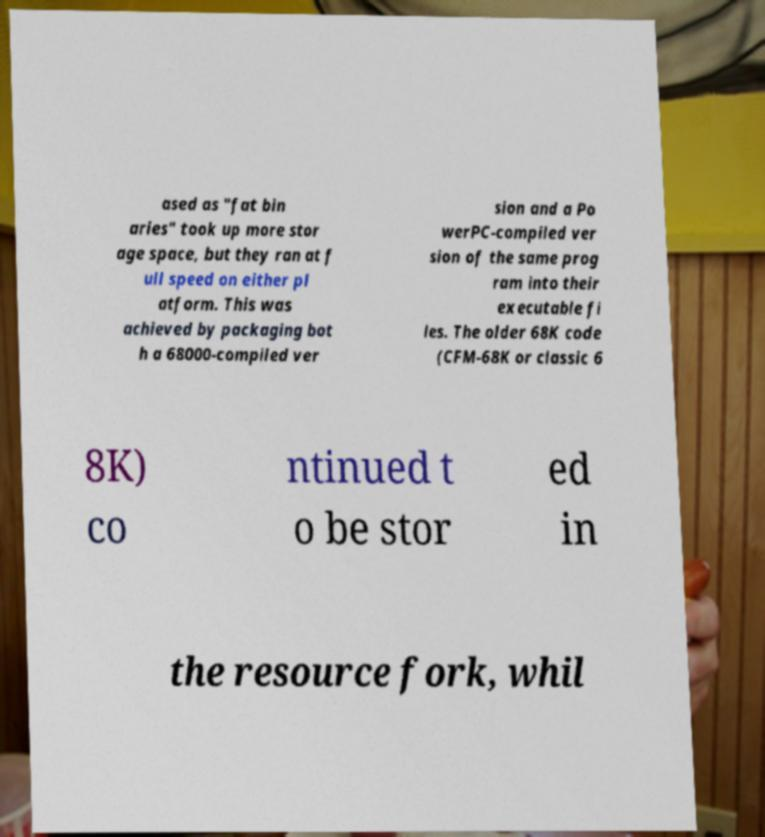Can you read and provide the text displayed in the image?This photo seems to have some interesting text. Can you extract and type it out for me? ased as "fat bin aries" took up more stor age space, but they ran at f ull speed on either pl atform. This was achieved by packaging bot h a 68000-compiled ver sion and a Po werPC-compiled ver sion of the same prog ram into their executable fi les. The older 68K code (CFM-68K or classic 6 8K) co ntinued t o be stor ed in the resource fork, whil 